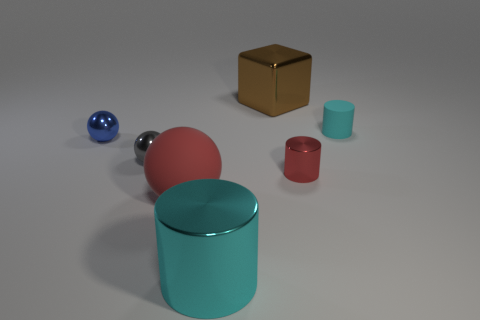Add 3 brown metallic cubes. How many objects exist? 10 Subtract all blocks. How many objects are left? 6 Subtract all small gray rubber cubes. Subtract all small cyan objects. How many objects are left? 6 Add 5 large brown shiny objects. How many large brown shiny objects are left? 6 Add 6 gray metallic objects. How many gray metallic objects exist? 7 Subtract 0 blue cylinders. How many objects are left? 7 